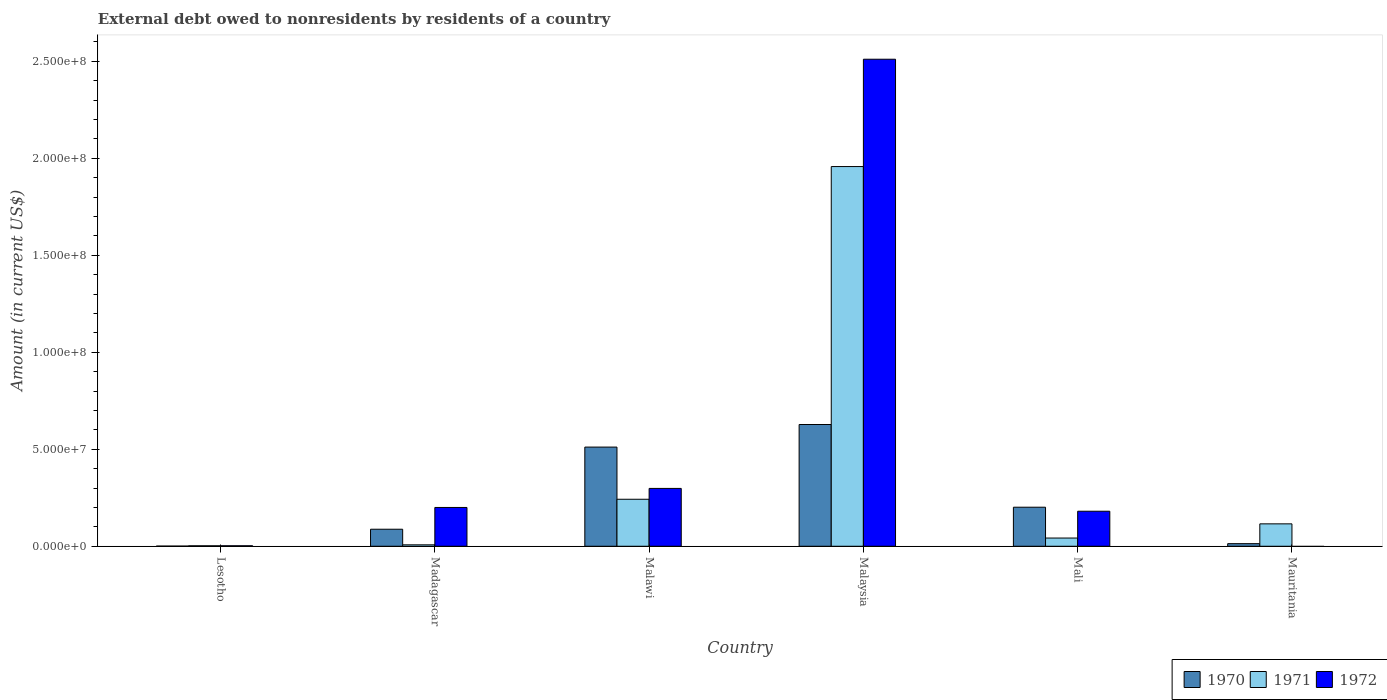How many different coloured bars are there?
Keep it short and to the point. 3. How many groups of bars are there?
Your answer should be compact. 6. Are the number of bars per tick equal to the number of legend labels?
Give a very brief answer. No. Are the number of bars on each tick of the X-axis equal?
Offer a terse response. No. How many bars are there on the 2nd tick from the right?
Give a very brief answer. 3. What is the label of the 5th group of bars from the left?
Give a very brief answer. Mali. What is the external debt owed by residents in 1971 in Mauritania?
Your answer should be compact. 1.15e+07. Across all countries, what is the maximum external debt owed by residents in 1971?
Provide a succinct answer. 1.96e+08. Across all countries, what is the minimum external debt owed by residents in 1971?
Ensure brevity in your answer.  2.36e+05. In which country was the external debt owed by residents in 1972 maximum?
Make the answer very short. Malaysia. What is the total external debt owed by residents in 1971 in the graph?
Your answer should be compact. 2.37e+08. What is the difference between the external debt owed by residents in 1970 in Lesotho and that in Madagascar?
Make the answer very short. -8.70e+06. What is the difference between the external debt owed by residents in 1972 in Malawi and the external debt owed by residents in 1971 in Malaysia?
Give a very brief answer. -1.66e+08. What is the average external debt owed by residents in 1972 per country?
Offer a terse response. 5.32e+07. What is the difference between the external debt owed by residents of/in 1971 and external debt owed by residents of/in 1970 in Mauritania?
Your answer should be very brief. 1.02e+07. In how many countries, is the external debt owed by residents in 1971 greater than 170000000 US$?
Give a very brief answer. 1. What is the ratio of the external debt owed by residents in 1971 in Madagascar to that in Malawi?
Keep it short and to the point. 0.03. Is the external debt owed by residents in 1971 in Lesotho less than that in Malaysia?
Offer a very short reply. Yes. Is the difference between the external debt owed by residents in 1971 in Malawi and Mali greater than the difference between the external debt owed by residents in 1970 in Malawi and Mali?
Your answer should be very brief. No. What is the difference between the highest and the second highest external debt owed by residents in 1972?
Provide a succinct answer. 2.21e+08. What is the difference between the highest and the lowest external debt owed by residents in 1970?
Provide a succinct answer. 6.27e+07. In how many countries, is the external debt owed by residents in 1972 greater than the average external debt owed by residents in 1972 taken over all countries?
Provide a succinct answer. 1. Is it the case that in every country, the sum of the external debt owed by residents in 1970 and external debt owed by residents in 1972 is greater than the external debt owed by residents in 1971?
Offer a terse response. No. What is the difference between two consecutive major ticks on the Y-axis?
Keep it short and to the point. 5.00e+07. Does the graph contain any zero values?
Provide a short and direct response. Yes. How many legend labels are there?
Give a very brief answer. 3. How are the legend labels stacked?
Your answer should be very brief. Horizontal. What is the title of the graph?
Give a very brief answer. External debt owed to nonresidents by residents of a country. What is the label or title of the X-axis?
Give a very brief answer. Country. What is the Amount (in current US$) in 1970 in Lesotho?
Keep it short and to the point. 7.60e+04. What is the Amount (in current US$) of 1971 in Lesotho?
Provide a succinct answer. 2.36e+05. What is the Amount (in current US$) in 1970 in Madagascar?
Give a very brief answer. 8.78e+06. What is the Amount (in current US$) of 1971 in Madagascar?
Provide a succinct answer. 7.30e+05. What is the Amount (in current US$) of 1972 in Madagascar?
Your answer should be compact. 2.00e+07. What is the Amount (in current US$) of 1970 in Malawi?
Keep it short and to the point. 5.11e+07. What is the Amount (in current US$) in 1971 in Malawi?
Provide a short and direct response. 2.42e+07. What is the Amount (in current US$) in 1972 in Malawi?
Offer a very short reply. 2.98e+07. What is the Amount (in current US$) of 1970 in Malaysia?
Your response must be concise. 6.28e+07. What is the Amount (in current US$) in 1971 in Malaysia?
Give a very brief answer. 1.96e+08. What is the Amount (in current US$) in 1972 in Malaysia?
Offer a very short reply. 2.51e+08. What is the Amount (in current US$) of 1970 in Mali?
Offer a very short reply. 2.01e+07. What is the Amount (in current US$) of 1971 in Mali?
Your answer should be very brief. 4.24e+06. What is the Amount (in current US$) of 1972 in Mali?
Give a very brief answer. 1.81e+07. What is the Amount (in current US$) in 1970 in Mauritania?
Your answer should be compact. 1.34e+06. What is the Amount (in current US$) in 1971 in Mauritania?
Provide a succinct answer. 1.15e+07. Across all countries, what is the maximum Amount (in current US$) in 1970?
Offer a terse response. 6.28e+07. Across all countries, what is the maximum Amount (in current US$) of 1971?
Make the answer very short. 1.96e+08. Across all countries, what is the maximum Amount (in current US$) in 1972?
Ensure brevity in your answer.  2.51e+08. Across all countries, what is the minimum Amount (in current US$) of 1970?
Offer a very short reply. 7.60e+04. Across all countries, what is the minimum Amount (in current US$) in 1971?
Ensure brevity in your answer.  2.36e+05. Across all countries, what is the minimum Amount (in current US$) of 1972?
Keep it short and to the point. 0. What is the total Amount (in current US$) of 1970 in the graph?
Your answer should be compact. 1.44e+08. What is the total Amount (in current US$) of 1971 in the graph?
Give a very brief answer. 2.37e+08. What is the total Amount (in current US$) in 1972 in the graph?
Provide a succinct answer. 3.19e+08. What is the difference between the Amount (in current US$) in 1970 in Lesotho and that in Madagascar?
Provide a short and direct response. -8.70e+06. What is the difference between the Amount (in current US$) of 1971 in Lesotho and that in Madagascar?
Offer a very short reply. -4.94e+05. What is the difference between the Amount (in current US$) in 1972 in Lesotho and that in Madagascar?
Your answer should be very brief. -1.97e+07. What is the difference between the Amount (in current US$) of 1970 in Lesotho and that in Malawi?
Offer a terse response. -5.10e+07. What is the difference between the Amount (in current US$) of 1971 in Lesotho and that in Malawi?
Offer a terse response. -2.40e+07. What is the difference between the Amount (in current US$) of 1972 in Lesotho and that in Malawi?
Your answer should be very brief. -2.96e+07. What is the difference between the Amount (in current US$) in 1970 in Lesotho and that in Malaysia?
Your answer should be compact. -6.27e+07. What is the difference between the Amount (in current US$) of 1971 in Lesotho and that in Malaysia?
Give a very brief answer. -1.95e+08. What is the difference between the Amount (in current US$) of 1972 in Lesotho and that in Malaysia?
Offer a very short reply. -2.51e+08. What is the difference between the Amount (in current US$) of 1970 in Lesotho and that in Mali?
Your answer should be very brief. -2.01e+07. What is the difference between the Amount (in current US$) of 1972 in Lesotho and that in Mali?
Make the answer very short. -1.78e+07. What is the difference between the Amount (in current US$) of 1970 in Lesotho and that in Mauritania?
Give a very brief answer. -1.26e+06. What is the difference between the Amount (in current US$) of 1971 in Lesotho and that in Mauritania?
Your answer should be compact. -1.13e+07. What is the difference between the Amount (in current US$) of 1970 in Madagascar and that in Malawi?
Provide a succinct answer. -4.23e+07. What is the difference between the Amount (in current US$) of 1971 in Madagascar and that in Malawi?
Offer a terse response. -2.35e+07. What is the difference between the Amount (in current US$) of 1972 in Madagascar and that in Malawi?
Your answer should be compact. -9.82e+06. What is the difference between the Amount (in current US$) in 1970 in Madagascar and that in Malaysia?
Offer a very short reply. -5.40e+07. What is the difference between the Amount (in current US$) in 1971 in Madagascar and that in Malaysia?
Offer a very short reply. -1.95e+08. What is the difference between the Amount (in current US$) in 1972 in Madagascar and that in Malaysia?
Provide a succinct answer. -2.31e+08. What is the difference between the Amount (in current US$) of 1970 in Madagascar and that in Mali?
Provide a short and direct response. -1.14e+07. What is the difference between the Amount (in current US$) of 1971 in Madagascar and that in Mali?
Provide a short and direct response. -3.51e+06. What is the difference between the Amount (in current US$) of 1972 in Madagascar and that in Mali?
Give a very brief answer. 1.94e+06. What is the difference between the Amount (in current US$) of 1970 in Madagascar and that in Mauritania?
Offer a terse response. 7.44e+06. What is the difference between the Amount (in current US$) of 1971 in Madagascar and that in Mauritania?
Give a very brief answer. -1.08e+07. What is the difference between the Amount (in current US$) in 1970 in Malawi and that in Malaysia?
Your response must be concise. -1.16e+07. What is the difference between the Amount (in current US$) of 1971 in Malawi and that in Malaysia?
Ensure brevity in your answer.  -1.72e+08. What is the difference between the Amount (in current US$) in 1972 in Malawi and that in Malaysia?
Ensure brevity in your answer.  -2.21e+08. What is the difference between the Amount (in current US$) of 1970 in Malawi and that in Mali?
Make the answer very short. 3.10e+07. What is the difference between the Amount (in current US$) of 1971 in Malawi and that in Mali?
Your answer should be compact. 2.00e+07. What is the difference between the Amount (in current US$) in 1972 in Malawi and that in Mali?
Ensure brevity in your answer.  1.18e+07. What is the difference between the Amount (in current US$) in 1970 in Malawi and that in Mauritania?
Your answer should be very brief. 4.98e+07. What is the difference between the Amount (in current US$) of 1971 in Malawi and that in Mauritania?
Offer a very short reply. 1.27e+07. What is the difference between the Amount (in current US$) in 1970 in Malaysia and that in Mali?
Your response must be concise. 4.26e+07. What is the difference between the Amount (in current US$) of 1971 in Malaysia and that in Mali?
Keep it short and to the point. 1.91e+08. What is the difference between the Amount (in current US$) of 1972 in Malaysia and that in Mali?
Offer a very short reply. 2.33e+08. What is the difference between the Amount (in current US$) of 1970 in Malaysia and that in Mauritania?
Ensure brevity in your answer.  6.14e+07. What is the difference between the Amount (in current US$) of 1971 in Malaysia and that in Mauritania?
Offer a very short reply. 1.84e+08. What is the difference between the Amount (in current US$) in 1970 in Mali and that in Mauritania?
Your answer should be very brief. 1.88e+07. What is the difference between the Amount (in current US$) of 1971 in Mali and that in Mauritania?
Provide a short and direct response. -7.31e+06. What is the difference between the Amount (in current US$) of 1970 in Lesotho and the Amount (in current US$) of 1971 in Madagascar?
Your answer should be very brief. -6.54e+05. What is the difference between the Amount (in current US$) of 1970 in Lesotho and the Amount (in current US$) of 1972 in Madagascar?
Keep it short and to the point. -1.99e+07. What is the difference between the Amount (in current US$) in 1971 in Lesotho and the Amount (in current US$) in 1972 in Madagascar?
Your answer should be compact. -1.98e+07. What is the difference between the Amount (in current US$) of 1970 in Lesotho and the Amount (in current US$) of 1971 in Malawi?
Give a very brief answer. -2.42e+07. What is the difference between the Amount (in current US$) in 1970 in Lesotho and the Amount (in current US$) in 1972 in Malawi?
Your answer should be very brief. -2.97e+07. What is the difference between the Amount (in current US$) in 1971 in Lesotho and the Amount (in current US$) in 1972 in Malawi?
Provide a succinct answer. -2.96e+07. What is the difference between the Amount (in current US$) of 1970 in Lesotho and the Amount (in current US$) of 1971 in Malaysia?
Your answer should be compact. -1.96e+08. What is the difference between the Amount (in current US$) of 1970 in Lesotho and the Amount (in current US$) of 1972 in Malaysia?
Give a very brief answer. -2.51e+08. What is the difference between the Amount (in current US$) in 1971 in Lesotho and the Amount (in current US$) in 1972 in Malaysia?
Ensure brevity in your answer.  -2.51e+08. What is the difference between the Amount (in current US$) in 1970 in Lesotho and the Amount (in current US$) in 1971 in Mali?
Provide a short and direct response. -4.16e+06. What is the difference between the Amount (in current US$) of 1970 in Lesotho and the Amount (in current US$) of 1972 in Mali?
Offer a very short reply. -1.80e+07. What is the difference between the Amount (in current US$) of 1971 in Lesotho and the Amount (in current US$) of 1972 in Mali?
Make the answer very short. -1.78e+07. What is the difference between the Amount (in current US$) of 1970 in Lesotho and the Amount (in current US$) of 1971 in Mauritania?
Offer a very short reply. -1.15e+07. What is the difference between the Amount (in current US$) in 1970 in Madagascar and the Amount (in current US$) in 1971 in Malawi?
Give a very brief answer. -1.55e+07. What is the difference between the Amount (in current US$) in 1970 in Madagascar and the Amount (in current US$) in 1972 in Malawi?
Make the answer very short. -2.10e+07. What is the difference between the Amount (in current US$) of 1971 in Madagascar and the Amount (in current US$) of 1972 in Malawi?
Your answer should be very brief. -2.91e+07. What is the difference between the Amount (in current US$) of 1970 in Madagascar and the Amount (in current US$) of 1971 in Malaysia?
Provide a short and direct response. -1.87e+08. What is the difference between the Amount (in current US$) of 1970 in Madagascar and the Amount (in current US$) of 1972 in Malaysia?
Your answer should be compact. -2.42e+08. What is the difference between the Amount (in current US$) of 1971 in Madagascar and the Amount (in current US$) of 1972 in Malaysia?
Offer a very short reply. -2.50e+08. What is the difference between the Amount (in current US$) of 1970 in Madagascar and the Amount (in current US$) of 1971 in Mali?
Your answer should be compact. 4.54e+06. What is the difference between the Amount (in current US$) of 1970 in Madagascar and the Amount (in current US$) of 1972 in Mali?
Offer a terse response. -9.28e+06. What is the difference between the Amount (in current US$) in 1971 in Madagascar and the Amount (in current US$) in 1972 in Mali?
Keep it short and to the point. -1.73e+07. What is the difference between the Amount (in current US$) in 1970 in Madagascar and the Amount (in current US$) in 1971 in Mauritania?
Ensure brevity in your answer.  -2.77e+06. What is the difference between the Amount (in current US$) in 1970 in Malawi and the Amount (in current US$) in 1971 in Malaysia?
Ensure brevity in your answer.  -1.45e+08. What is the difference between the Amount (in current US$) of 1970 in Malawi and the Amount (in current US$) of 1972 in Malaysia?
Your response must be concise. -2.00e+08. What is the difference between the Amount (in current US$) in 1971 in Malawi and the Amount (in current US$) in 1972 in Malaysia?
Provide a short and direct response. -2.27e+08. What is the difference between the Amount (in current US$) of 1970 in Malawi and the Amount (in current US$) of 1971 in Mali?
Keep it short and to the point. 4.69e+07. What is the difference between the Amount (in current US$) in 1970 in Malawi and the Amount (in current US$) in 1972 in Mali?
Make the answer very short. 3.31e+07. What is the difference between the Amount (in current US$) in 1971 in Malawi and the Amount (in current US$) in 1972 in Mali?
Offer a very short reply. 6.17e+06. What is the difference between the Amount (in current US$) in 1970 in Malawi and the Amount (in current US$) in 1971 in Mauritania?
Provide a succinct answer. 3.96e+07. What is the difference between the Amount (in current US$) in 1970 in Malaysia and the Amount (in current US$) in 1971 in Mali?
Keep it short and to the point. 5.85e+07. What is the difference between the Amount (in current US$) in 1970 in Malaysia and the Amount (in current US$) in 1972 in Mali?
Provide a short and direct response. 4.47e+07. What is the difference between the Amount (in current US$) of 1971 in Malaysia and the Amount (in current US$) of 1972 in Mali?
Make the answer very short. 1.78e+08. What is the difference between the Amount (in current US$) of 1970 in Malaysia and the Amount (in current US$) of 1971 in Mauritania?
Ensure brevity in your answer.  5.12e+07. What is the difference between the Amount (in current US$) of 1970 in Mali and the Amount (in current US$) of 1971 in Mauritania?
Give a very brief answer. 8.58e+06. What is the average Amount (in current US$) in 1970 per country?
Your answer should be compact. 2.40e+07. What is the average Amount (in current US$) of 1971 per country?
Your response must be concise. 3.95e+07. What is the average Amount (in current US$) of 1972 per country?
Give a very brief answer. 5.32e+07. What is the difference between the Amount (in current US$) of 1970 and Amount (in current US$) of 1971 in Lesotho?
Keep it short and to the point. -1.60e+05. What is the difference between the Amount (in current US$) in 1970 and Amount (in current US$) in 1972 in Lesotho?
Your response must be concise. -1.74e+05. What is the difference between the Amount (in current US$) in 1971 and Amount (in current US$) in 1972 in Lesotho?
Ensure brevity in your answer.  -1.40e+04. What is the difference between the Amount (in current US$) of 1970 and Amount (in current US$) of 1971 in Madagascar?
Offer a very short reply. 8.04e+06. What is the difference between the Amount (in current US$) in 1970 and Amount (in current US$) in 1972 in Madagascar?
Your answer should be very brief. -1.12e+07. What is the difference between the Amount (in current US$) in 1971 and Amount (in current US$) in 1972 in Madagascar?
Make the answer very short. -1.93e+07. What is the difference between the Amount (in current US$) of 1970 and Amount (in current US$) of 1971 in Malawi?
Provide a short and direct response. 2.69e+07. What is the difference between the Amount (in current US$) of 1970 and Amount (in current US$) of 1972 in Malawi?
Offer a very short reply. 2.13e+07. What is the difference between the Amount (in current US$) in 1971 and Amount (in current US$) in 1972 in Malawi?
Ensure brevity in your answer.  -5.59e+06. What is the difference between the Amount (in current US$) in 1970 and Amount (in current US$) in 1971 in Malaysia?
Keep it short and to the point. -1.33e+08. What is the difference between the Amount (in current US$) of 1970 and Amount (in current US$) of 1972 in Malaysia?
Offer a terse response. -1.88e+08. What is the difference between the Amount (in current US$) of 1971 and Amount (in current US$) of 1972 in Malaysia?
Make the answer very short. -5.53e+07. What is the difference between the Amount (in current US$) of 1970 and Amount (in current US$) of 1971 in Mali?
Make the answer very short. 1.59e+07. What is the difference between the Amount (in current US$) in 1970 and Amount (in current US$) in 1972 in Mali?
Give a very brief answer. 2.07e+06. What is the difference between the Amount (in current US$) in 1971 and Amount (in current US$) in 1972 in Mali?
Ensure brevity in your answer.  -1.38e+07. What is the difference between the Amount (in current US$) in 1970 and Amount (in current US$) in 1971 in Mauritania?
Provide a short and direct response. -1.02e+07. What is the ratio of the Amount (in current US$) in 1970 in Lesotho to that in Madagascar?
Give a very brief answer. 0.01. What is the ratio of the Amount (in current US$) of 1971 in Lesotho to that in Madagascar?
Ensure brevity in your answer.  0.32. What is the ratio of the Amount (in current US$) in 1972 in Lesotho to that in Madagascar?
Keep it short and to the point. 0.01. What is the ratio of the Amount (in current US$) in 1970 in Lesotho to that in Malawi?
Your answer should be compact. 0. What is the ratio of the Amount (in current US$) in 1971 in Lesotho to that in Malawi?
Make the answer very short. 0.01. What is the ratio of the Amount (in current US$) in 1972 in Lesotho to that in Malawi?
Give a very brief answer. 0.01. What is the ratio of the Amount (in current US$) of 1970 in Lesotho to that in Malaysia?
Offer a terse response. 0. What is the ratio of the Amount (in current US$) of 1971 in Lesotho to that in Malaysia?
Offer a very short reply. 0. What is the ratio of the Amount (in current US$) of 1972 in Lesotho to that in Malaysia?
Keep it short and to the point. 0. What is the ratio of the Amount (in current US$) of 1970 in Lesotho to that in Mali?
Give a very brief answer. 0. What is the ratio of the Amount (in current US$) of 1971 in Lesotho to that in Mali?
Offer a very short reply. 0.06. What is the ratio of the Amount (in current US$) of 1972 in Lesotho to that in Mali?
Ensure brevity in your answer.  0.01. What is the ratio of the Amount (in current US$) of 1970 in Lesotho to that in Mauritania?
Provide a succinct answer. 0.06. What is the ratio of the Amount (in current US$) of 1971 in Lesotho to that in Mauritania?
Ensure brevity in your answer.  0.02. What is the ratio of the Amount (in current US$) in 1970 in Madagascar to that in Malawi?
Provide a short and direct response. 0.17. What is the ratio of the Amount (in current US$) of 1971 in Madagascar to that in Malawi?
Provide a short and direct response. 0.03. What is the ratio of the Amount (in current US$) in 1972 in Madagascar to that in Malawi?
Offer a very short reply. 0.67. What is the ratio of the Amount (in current US$) in 1970 in Madagascar to that in Malaysia?
Offer a terse response. 0.14. What is the ratio of the Amount (in current US$) of 1971 in Madagascar to that in Malaysia?
Keep it short and to the point. 0. What is the ratio of the Amount (in current US$) of 1972 in Madagascar to that in Malaysia?
Your response must be concise. 0.08. What is the ratio of the Amount (in current US$) in 1970 in Madagascar to that in Mali?
Offer a very short reply. 0.44. What is the ratio of the Amount (in current US$) in 1971 in Madagascar to that in Mali?
Your answer should be very brief. 0.17. What is the ratio of the Amount (in current US$) of 1972 in Madagascar to that in Mali?
Your answer should be compact. 1.11. What is the ratio of the Amount (in current US$) in 1970 in Madagascar to that in Mauritania?
Give a very brief answer. 6.56. What is the ratio of the Amount (in current US$) of 1971 in Madagascar to that in Mauritania?
Offer a very short reply. 0.06. What is the ratio of the Amount (in current US$) in 1970 in Malawi to that in Malaysia?
Offer a terse response. 0.81. What is the ratio of the Amount (in current US$) in 1971 in Malawi to that in Malaysia?
Provide a short and direct response. 0.12. What is the ratio of the Amount (in current US$) of 1972 in Malawi to that in Malaysia?
Offer a terse response. 0.12. What is the ratio of the Amount (in current US$) of 1970 in Malawi to that in Mali?
Offer a terse response. 2.54. What is the ratio of the Amount (in current US$) of 1971 in Malawi to that in Mali?
Give a very brief answer. 5.72. What is the ratio of the Amount (in current US$) of 1972 in Malawi to that in Mali?
Give a very brief answer. 1.65. What is the ratio of the Amount (in current US$) in 1970 in Malawi to that in Mauritania?
Your answer should be compact. 38.24. What is the ratio of the Amount (in current US$) in 1971 in Malawi to that in Mauritania?
Your answer should be compact. 2.1. What is the ratio of the Amount (in current US$) in 1970 in Malaysia to that in Mali?
Provide a short and direct response. 3.12. What is the ratio of the Amount (in current US$) of 1971 in Malaysia to that in Mali?
Provide a short and direct response. 46.21. What is the ratio of the Amount (in current US$) of 1972 in Malaysia to that in Mali?
Your response must be concise. 13.9. What is the ratio of the Amount (in current US$) in 1970 in Malaysia to that in Mauritania?
Your answer should be very brief. 46.94. What is the ratio of the Amount (in current US$) of 1971 in Malaysia to that in Mauritania?
Offer a very short reply. 16.96. What is the ratio of the Amount (in current US$) of 1970 in Mali to that in Mauritania?
Keep it short and to the point. 15.05. What is the ratio of the Amount (in current US$) of 1971 in Mali to that in Mauritania?
Provide a succinct answer. 0.37. What is the difference between the highest and the second highest Amount (in current US$) in 1970?
Your answer should be compact. 1.16e+07. What is the difference between the highest and the second highest Amount (in current US$) in 1971?
Make the answer very short. 1.72e+08. What is the difference between the highest and the second highest Amount (in current US$) in 1972?
Give a very brief answer. 2.21e+08. What is the difference between the highest and the lowest Amount (in current US$) in 1970?
Ensure brevity in your answer.  6.27e+07. What is the difference between the highest and the lowest Amount (in current US$) of 1971?
Give a very brief answer. 1.95e+08. What is the difference between the highest and the lowest Amount (in current US$) of 1972?
Provide a short and direct response. 2.51e+08. 